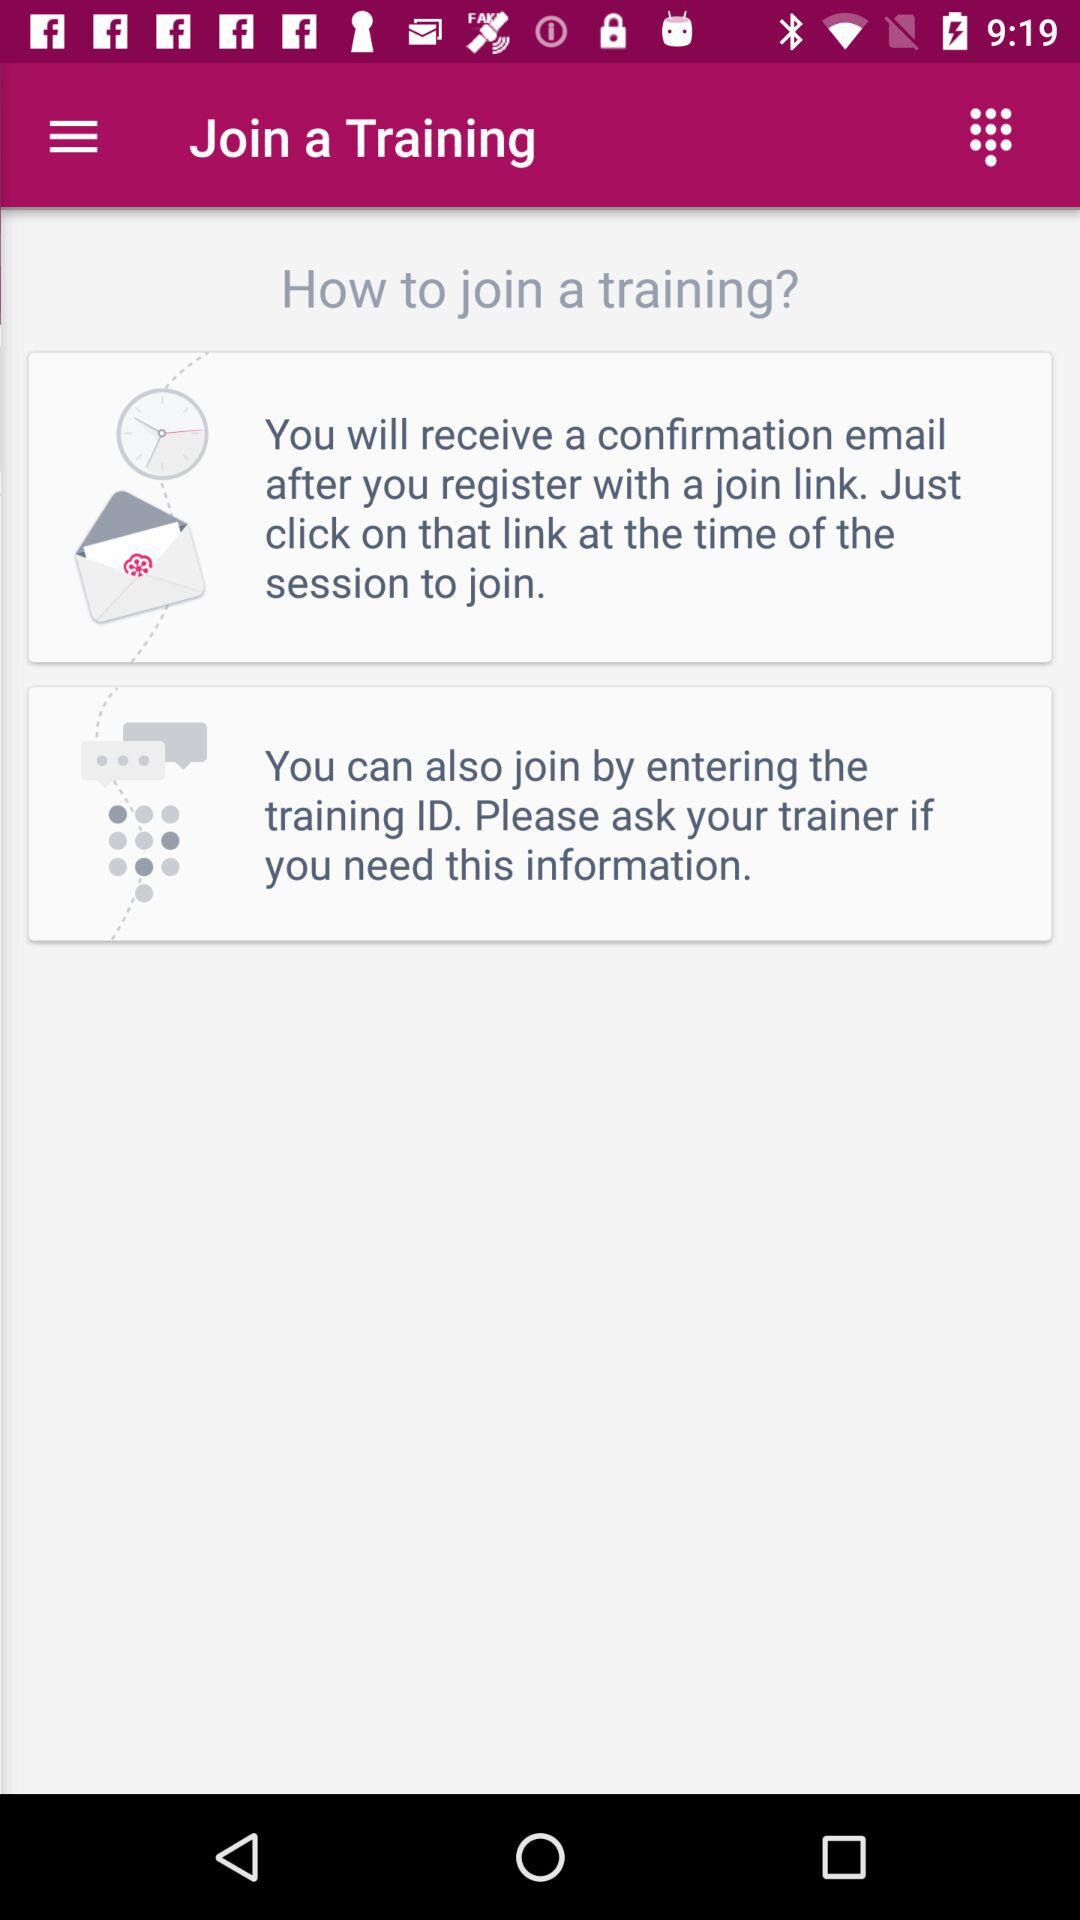How many steps are there to join a training?
Answer the question using a single word or phrase. 2 